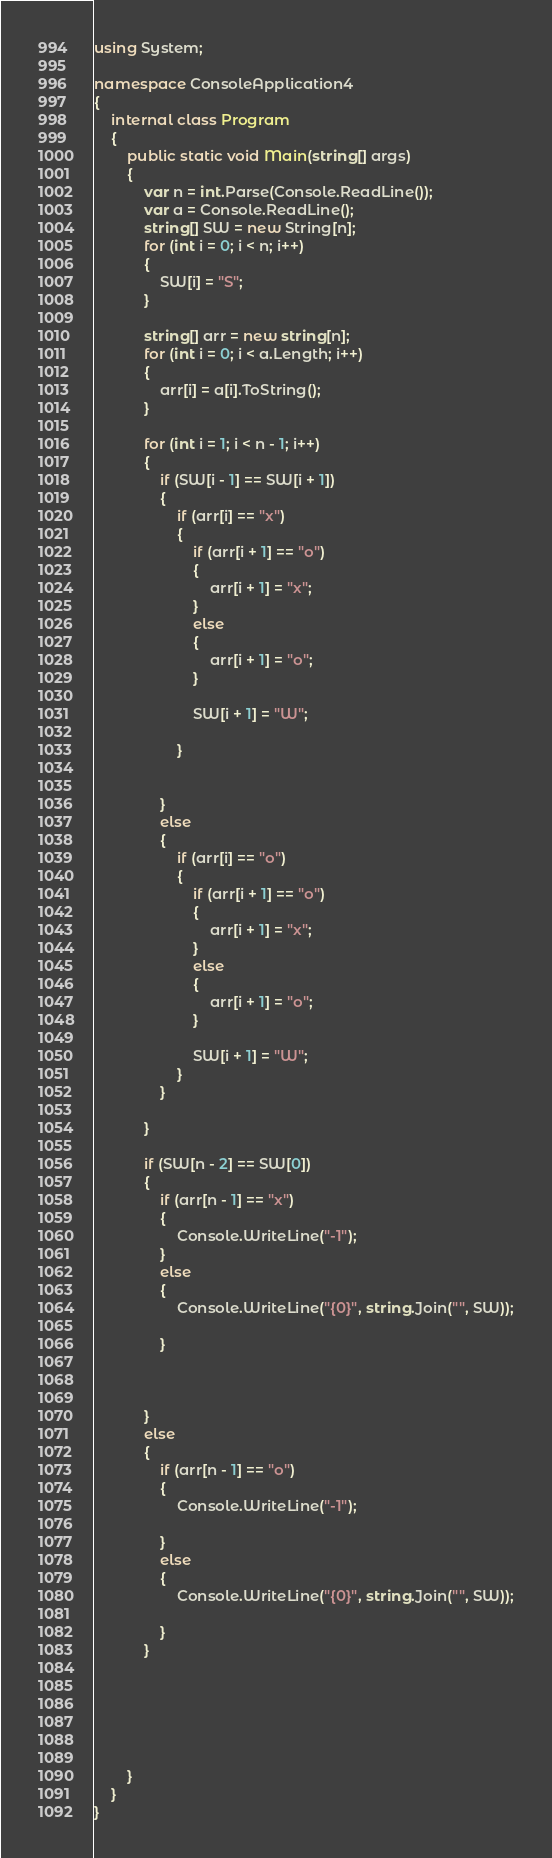Convert code to text. <code><loc_0><loc_0><loc_500><loc_500><_C#_>using System;

namespace ConsoleApplication4
{
    internal class Program
    {
        public static void Main(string[] args)
        {
            var n = int.Parse(Console.ReadLine());
            var a = Console.ReadLine();
            string[] SW = new String[n];
            for (int i = 0; i < n; i++)
            {
                SW[i] = "S";
            }

            string[] arr = new string[n];
            for (int i = 0; i < a.Length; i++)
            {
                arr[i] = a[i].ToString();
            }

            for (int i = 1; i < n - 1; i++)
            {
                if (SW[i - 1] == SW[i + 1])
                {
                    if (arr[i] == "x")
                    {
                        if (arr[i + 1] == "o")
                        {
                            arr[i + 1] = "x";
                        }
                        else
                        {
                            arr[i + 1] = "o";
                        }

                        SW[i + 1] = "W";

                    }


                }
                else
                {
                    if (arr[i] == "o")
                    {
                        if (arr[i + 1] == "o")
                        {
                            arr[i + 1] = "x";
                        }
                        else
                        {
                            arr[i + 1] = "o";
                        }

                        SW[i + 1] = "W";
                    }
                }

            }

            if (SW[n - 2] == SW[0])
            {
                if (arr[n - 1] == "x")
                {
                    Console.WriteLine("-1");
                }
                else
                {
                    Console.WriteLine("{0}", string.Join("", SW));

                }



            }
            else
            {
                if (arr[n - 1] == "o")
                {
                    Console.WriteLine("-1");

                }
                else
                {
                    Console.WriteLine("{0}", string.Join("", SW));

                }
            }






        }
    }
}</code> 